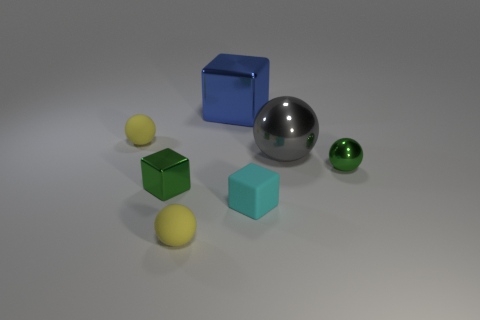What shape is the shiny object that is the same color as the tiny metal sphere?
Your answer should be very brief. Cube. Is the color of the tiny matte sphere behind the cyan rubber thing the same as the tiny matte block that is in front of the green block?
Provide a succinct answer. No. There is a large blue shiny object; how many big metal things are in front of it?
Your answer should be very brief. 1. What size is the thing that is the same color as the small metal ball?
Keep it short and to the point. Small. Are there any other cyan objects that have the same shape as the small cyan thing?
Offer a very short reply. No. There is another shiny thing that is the same size as the blue thing; what color is it?
Offer a very short reply. Gray. Are there fewer tiny cyan rubber objects behind the big blue block than small yellow rubber objects behind the green metallic sphere?
Provide a succinct answer. Yes. Does the matte object to the right of the blue shiny cube have the same size as the green metallic cube?
Keep it short and to the point. Yes. What is the shape of the small green metallic object on the right side of the tiny cyan rubber object?
Keep it short and to the point. Sphere. Is the number of small brown things greater than the number of small green objects?
Ensure brevity in your answer.  No. 